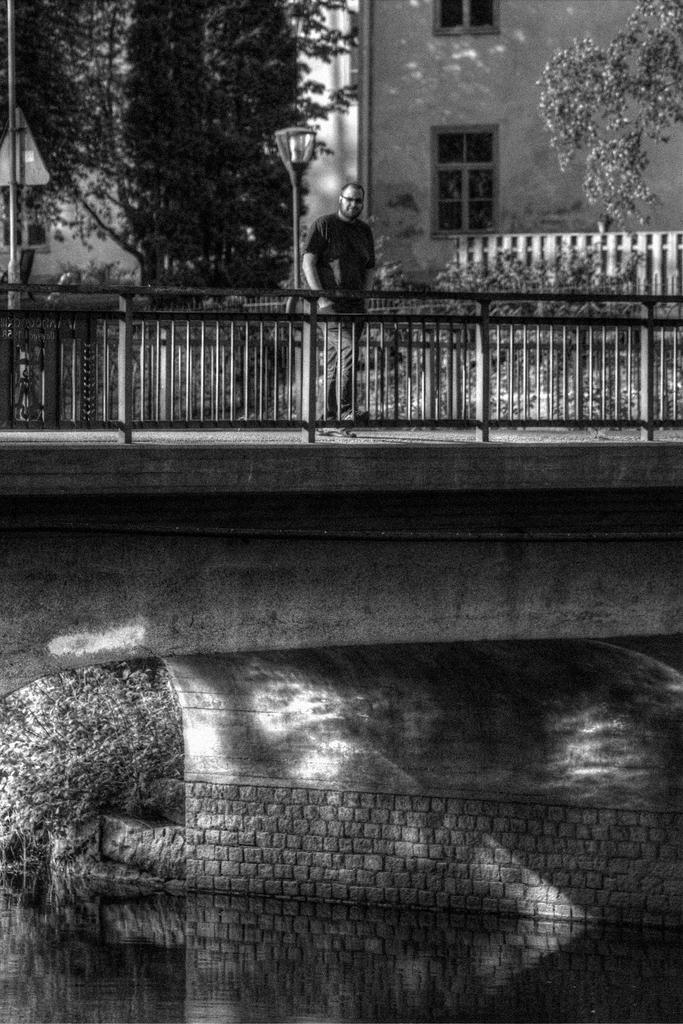How would you summarize this image in a sentence or two? This is black and white image on that bridge there is man is standing near a railing, in the background there are trees and building. 